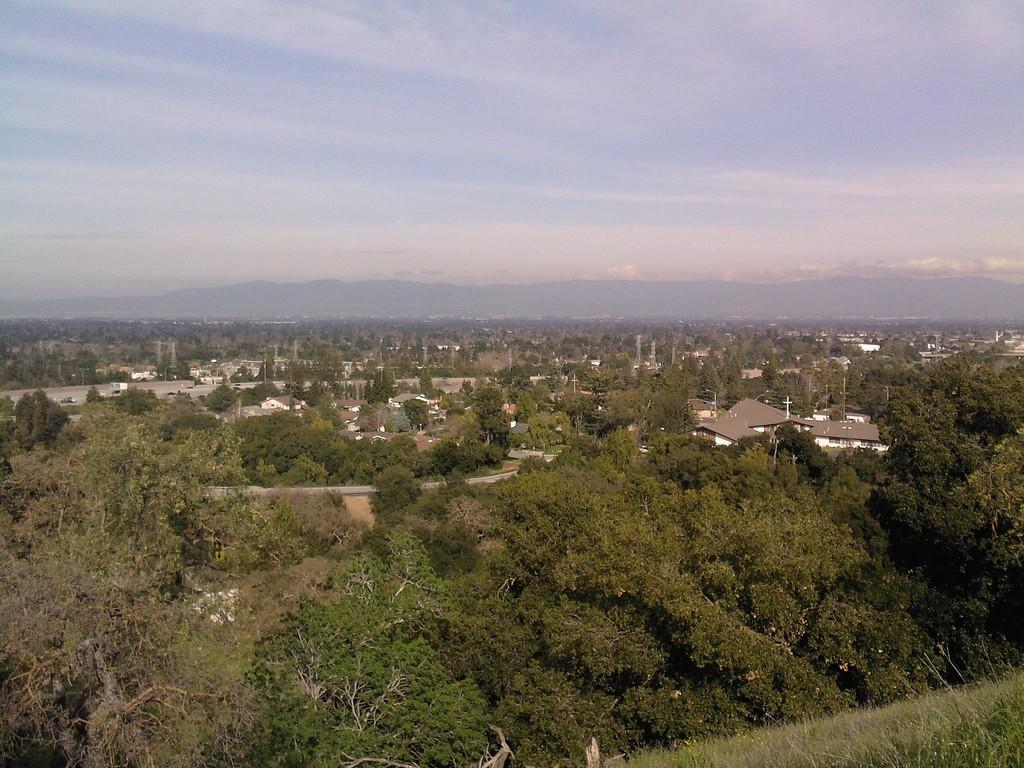What type of vegetation can be seen in the image? There are trees in the image. What type of structures are present in the image? There are houses in the image. What natural landmarks can be seen in the background of the image? There are mountains visible in the background of the image. What colors are present in the sky in the image? The sky is blue and white in color. Where is the fifth tree located in the image? There is no mention of a fifth tree in the image, as the facts only mention trees in general. What type of stage can be seen in the image? There is no stage present in the image; it features trees, houses, mountains, and a blue and white sky. 